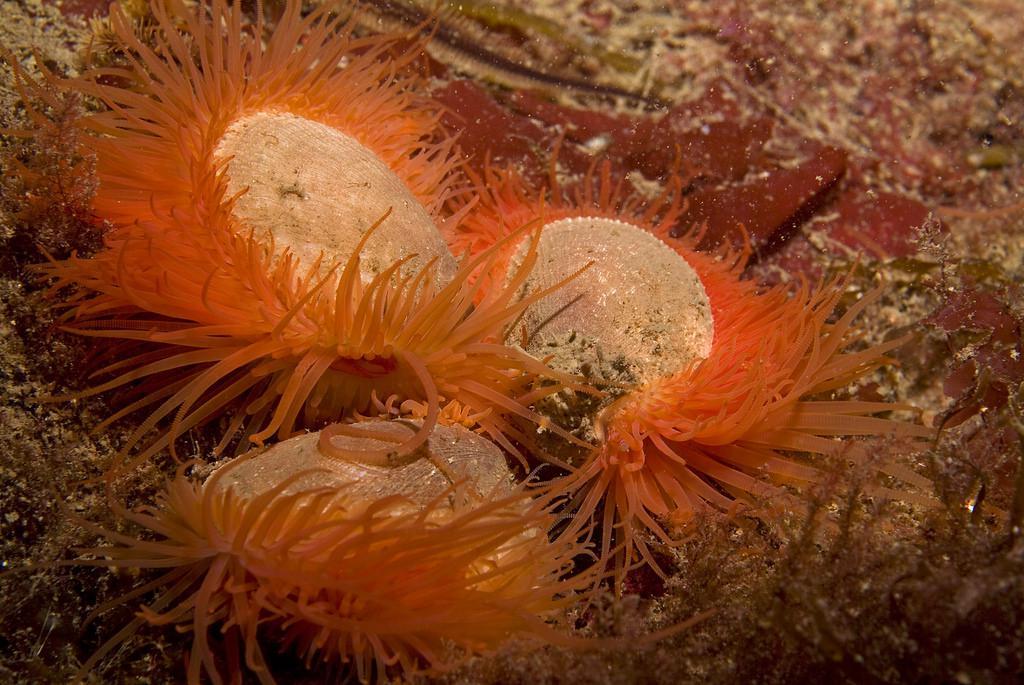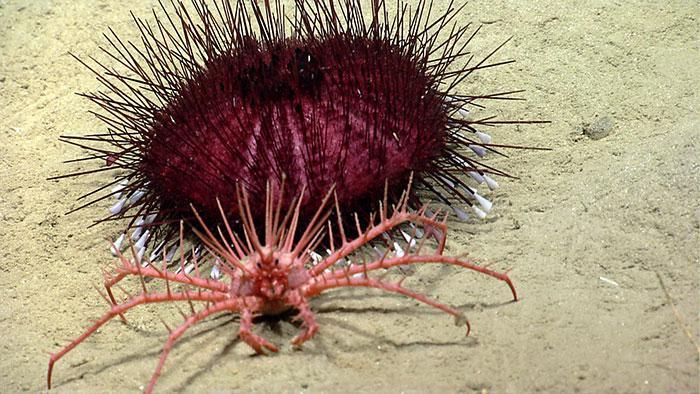The first image is the image on the left, the second image is the image on the right. Assess this claim about the two images: "All images feature anemone with tapering non-spike 'soft' tendrils, but one image features an anemone that has a deeper and more solid color than the other image.". Correct or not? Answer yes or no. No. 